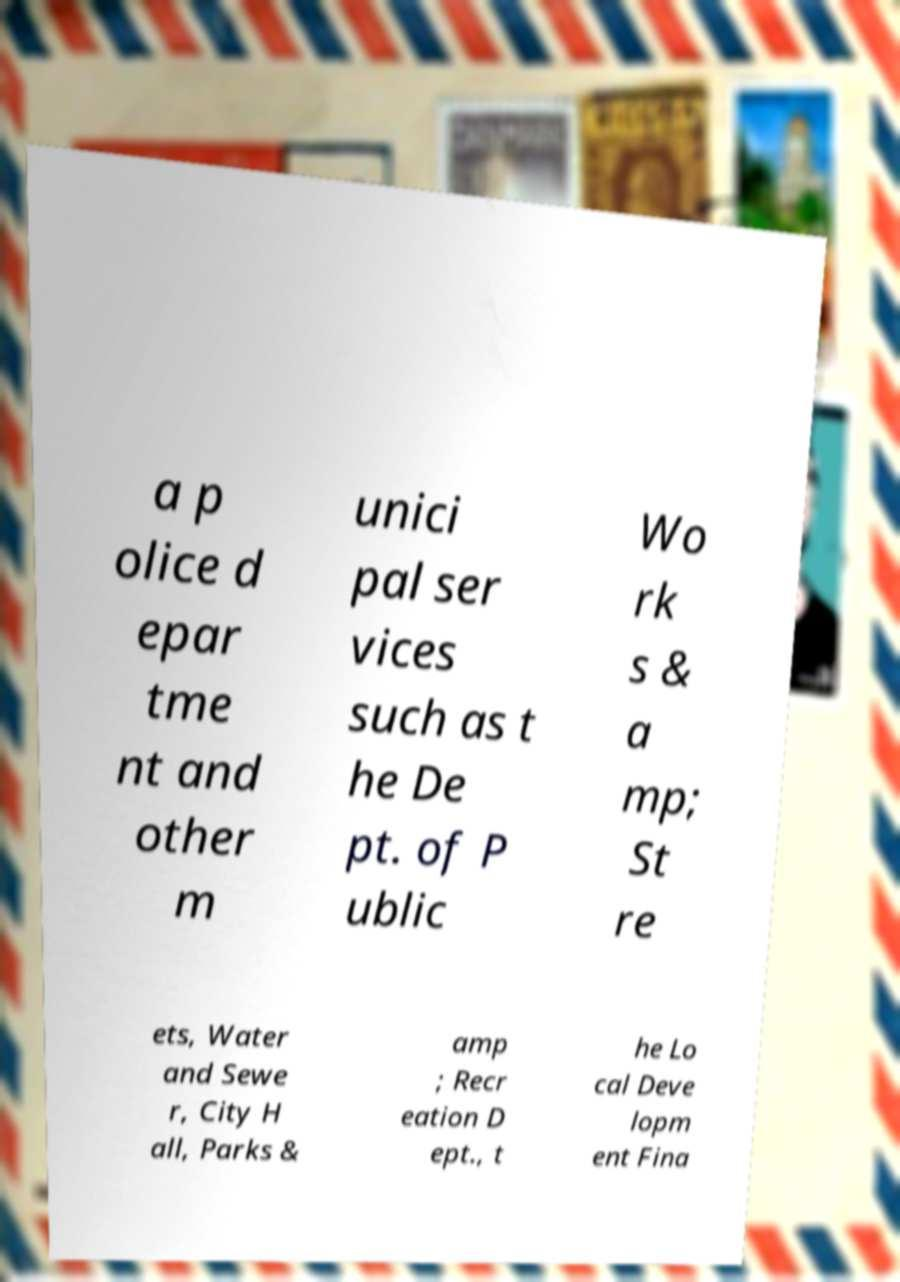Can you accurately transcribe the text from the provided image for me? a p olice d epar tme nt and other m unici pal ser vices such as t he De pt. of P ublic Wo rk s & a mp; St re ets, Water and Sewe r, City H all, Parks & amp ; Recr eation D ept., t he Lo cal Deve lopm ent Fina 